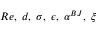<formula> <loc_0><loc_0><loc_500><loc_500>R e , \, d , \, \sigma , \, \epsilon , \, \alpha ^ { B J } , \, \xi</formula> 